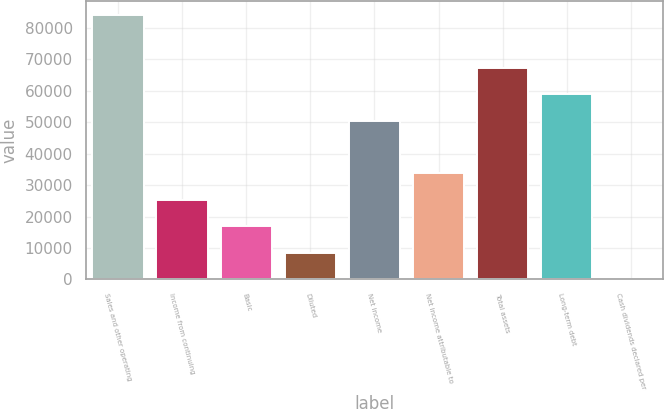Convert chart. <chart><loc_0><loc_0><loc_500><loc_500><bar_chart><fcel>Sales and other operating<fcel>Income from continuing<fcel>Basic<fcel>Diluted<fcel>Net income<fcel>Net income attributable to<fcel>Total assets<fcel>Long-term debt<fcel>Cash dividends declared per<nl><fcel>84279<fcel>25285.4<fcel>16857.8<fcel>8430.11<fcel>50568.4<fcel>33713.1<fcel>67423.7<fcel>58996<fcel>2.45<nl></chart> 